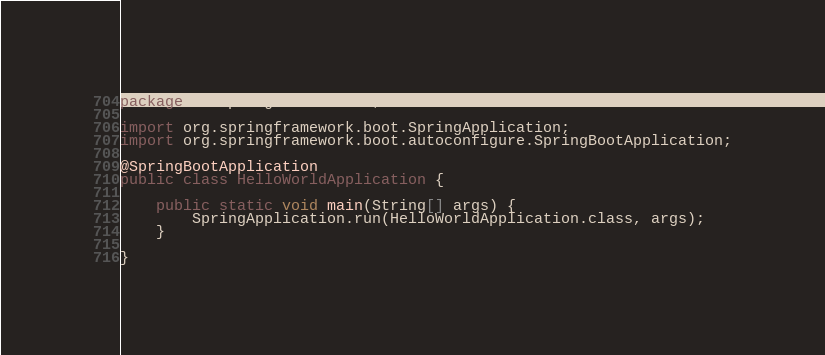<code> <loc_0><loc_0><loc_500><loc_500><_Java_>package io.spring.helloworld;

import org.springframework.boot.SpringApplication;
import org.springframework.boot.autoconfigure.SpringBootApplication;

@SpringBootApplication
public class HelloWorldApplication {

    public static void main(String[] args) {
        SpringApplication.run(HelloWorldApplication.class, args);
    }

}
</code> 